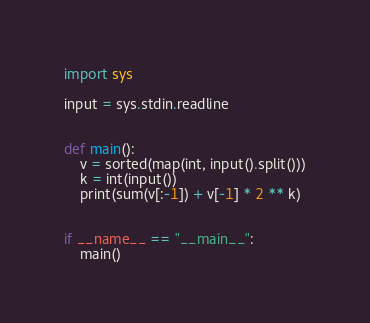Convert code to text. <code><loc_0><loc_0><loc_500><loc_500><_Python_>import sys

input = sys.stdin.readline


def main():
    v = sorted(map(int, input().split()))
    k = int(input())
    print(sum(v[:-1]) + v[-1] * 2 ** k)


if __name__ == "__main__":
    main()
</code> 